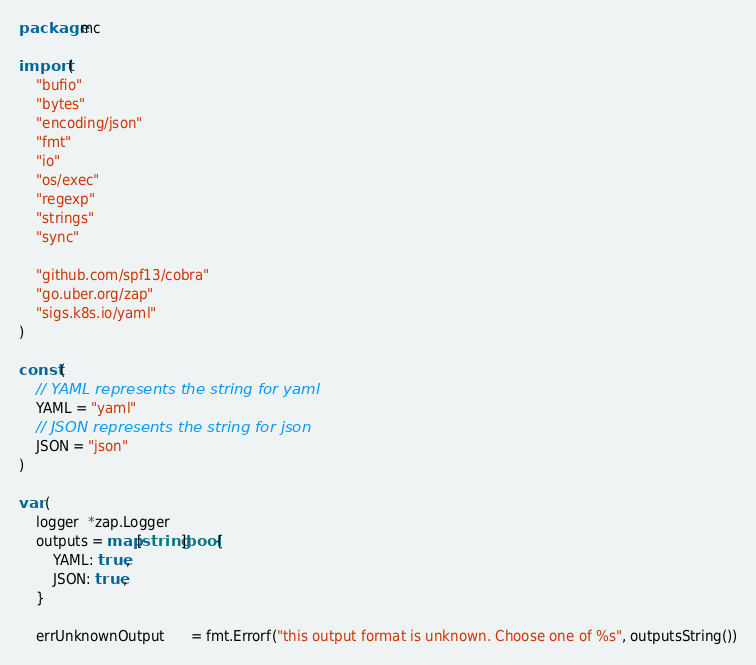Convert code to text. <code><loc_0><loc_0><loc_500><loc_500><_Go_>package mc

import (
	"bufio"
	"bytes"
	"encoding/json"
	"fmt"
	"io"
	"os/exec"
	"regexp"
	"strings"
	"sync"

	"github.com/spf13/cobra"
	"go.uber.org/zap"
	"sigs.k8s.io/yaml"
)

const (
	// YAML represents the string for yaml
	YAML = "yaml"
	// JSON represents the string for json
	JSON = "json"
)

var (
	logger  *zap.Logger
	outputs = map[string]bool{
		YAML: true,
		JSON: true,
	}

	errUnknownOutput      = fmt.Errorf("this output format is unknown. Choose one of %s", outputsString())</code> 